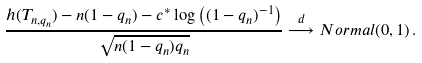<formula> <loc_0><loc_0><loc_500><loc_500>\frac { h ( T _ { n , q _ { n } } ) - n ( 1 - q _ { n } ) - c ^ { * } \log \left ( ( 1 - q _ { n } ) ^ { - 1 } \right ) } { \sqrt { n ( 1 - q _ { n } ) q _ { n } } } \overset { d } { \longrightarrow } N o r m a l ( 0 , 1 ) \, .</formula> 